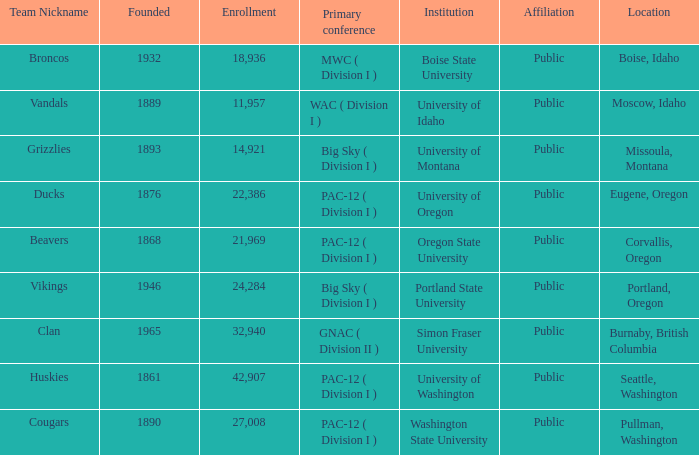What is the location of the team nicknamed Broncos, which was founded after 1889? Boise, Idaho. 